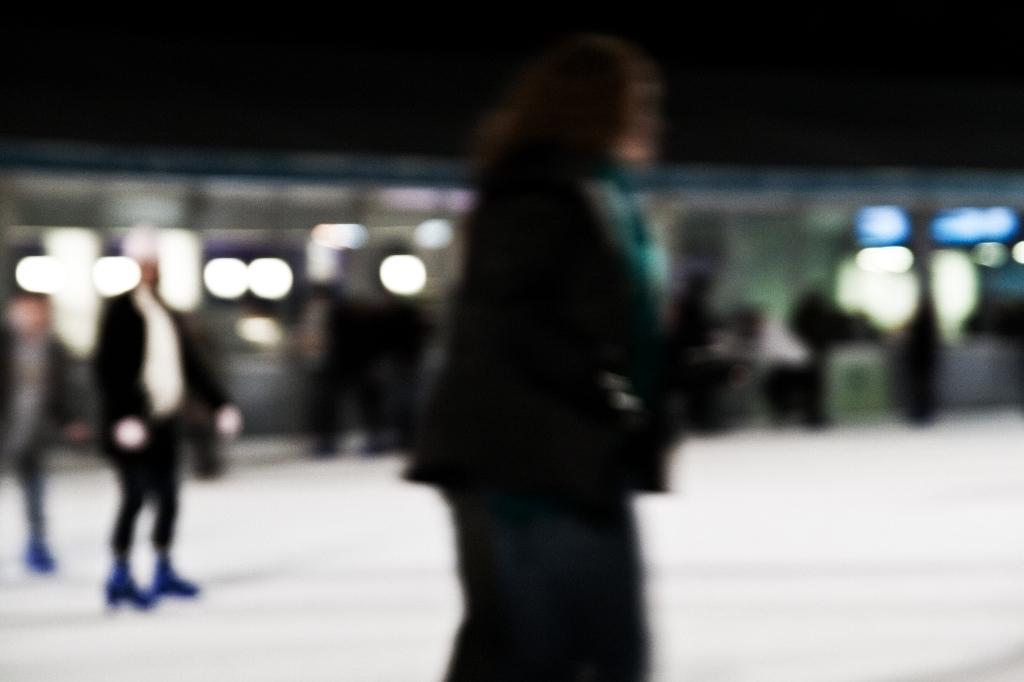Can you describe this image briefly? In this image I can see people standing, there are lights at the back. This is a blurred image. 